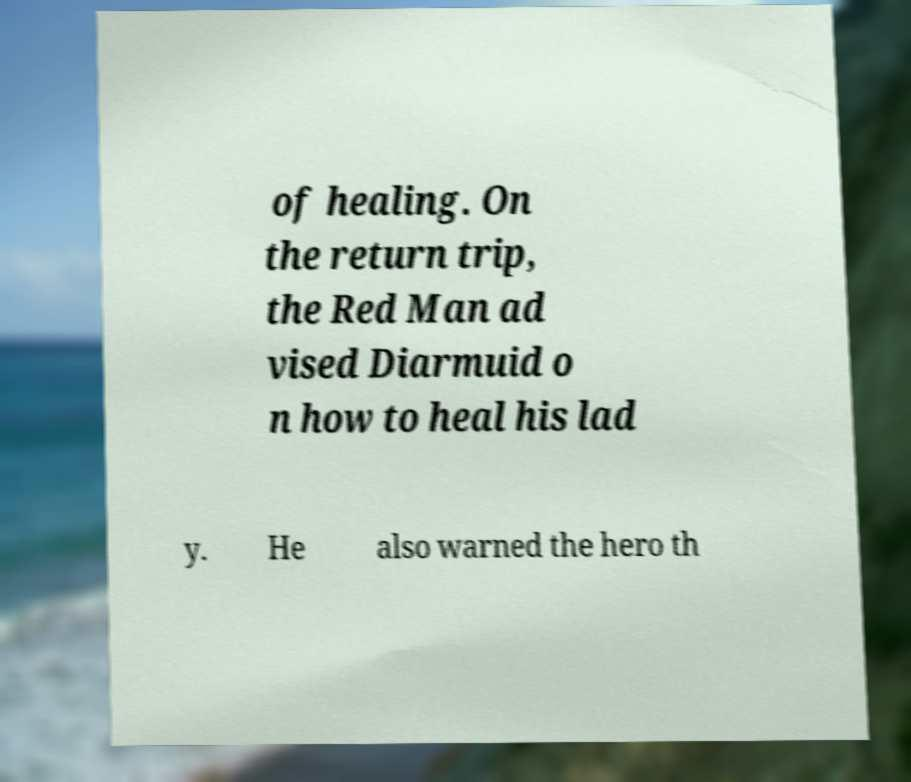Can you read and provide the text displayed in the image?This photo seems to have some interesting text. Can you extract and type it out for me? of healing. On the return trip, the Red Man ad vised Diarmuid o n how to heal his lad y. He also warned the hero th 